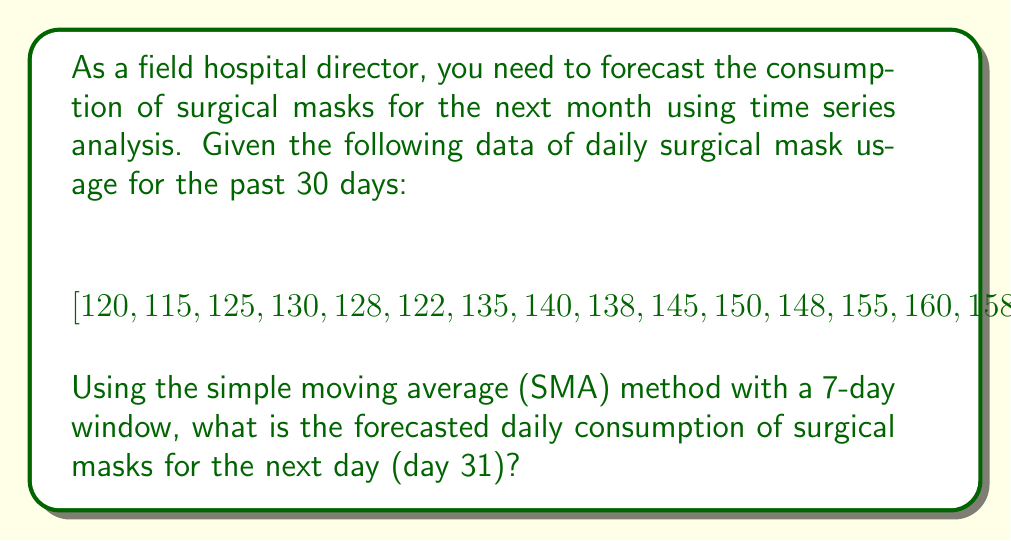Show me your answer to this math problem. To forecast the daily consumption of surgical masks using the simple moving average (SMA) method with a 7-day window, we'll follow these steps:

1. Calculate the SMA for the last 7 days of available data:
   $$SMA = \frac{198 + 205 + 210 + 208 + 195 + 200 + 198}{7}$$

2. Perform the calculation:
   $$SMA = \frac{1414}{7} = 202$$

3. Round the result to the nearest whole number, as we can't use fractional masks.

The SMA method assumes that the forecast for the next day (day 31) will be equal to the calculated average of the previous 7 days.

This method is suitable for short-term forecasting in relatively stable environments. However, it's important to note that it doesn't account for trends or seasonality in the data. For more accurate long-term forecasting, more sophisticated time series analysis methods like ARIMA or exponential smoothing might be more appropriate.
Answer: 202 masks 